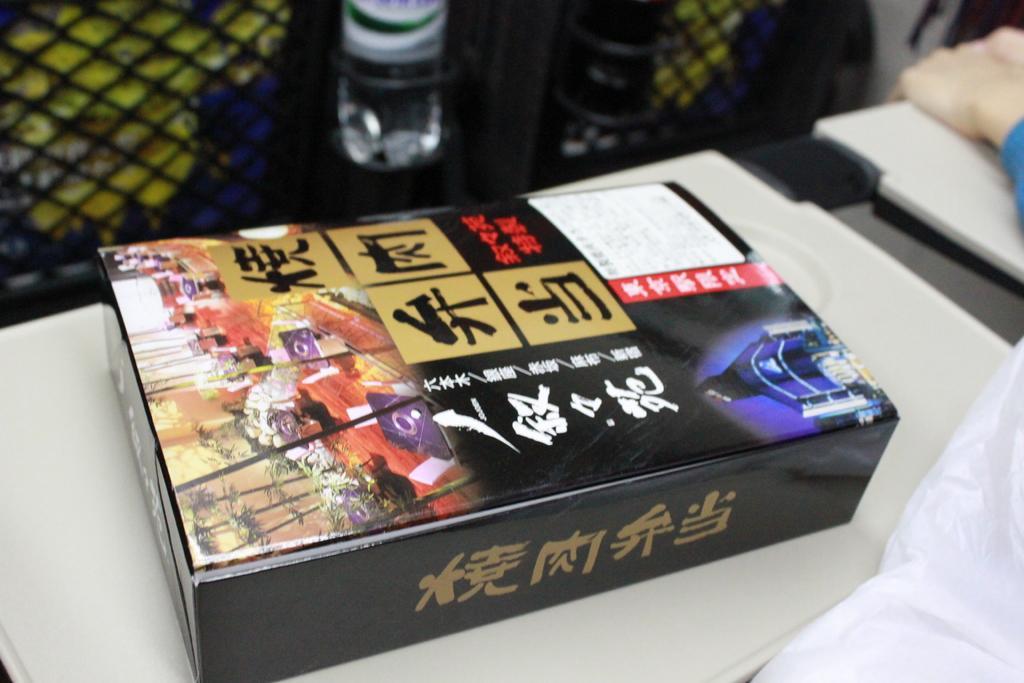In one or two sentences, can you explain what this image depicts? This is a picture of a box on white floor the box has some different color of things written on it black, red, blue, golden and there is a bottle beside the box. 